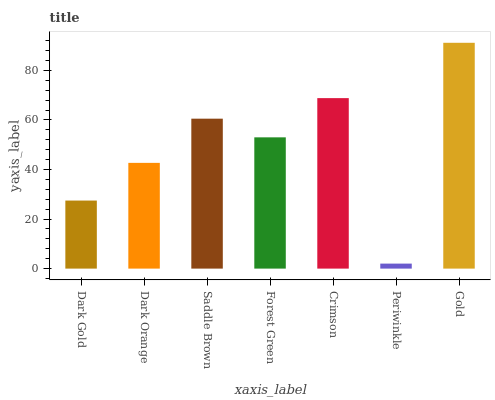Is Periwinkle the minimum?
Answer yes or no. Yes. Is Gold the maximum?
Answer yes or no. Yes. Is Dark Orange the minimum?
Answer yes or no. No. Is Dark Orange the maximum?
Answer yes or no. No. Is Dark Orange greater than Dark Gold?
Answer yes or no. Yes. Is Dark Gold less than Dark Orange?
Answer yes or no. Yes. Is Dark Gold greater than Dark Orange?
Answer yes or no. No. Is Dark Orange less than Dark Gold?
Answer yes or no. No. Is Forest Green the high median?
Answer yes or no. Yes. Is Forest Green the low median?
Answer yes or no. Yes. Is Dark Gold the high median?
Answer yes or no. No. Is Dark Gold the low median?
Answer yes or no. No. 